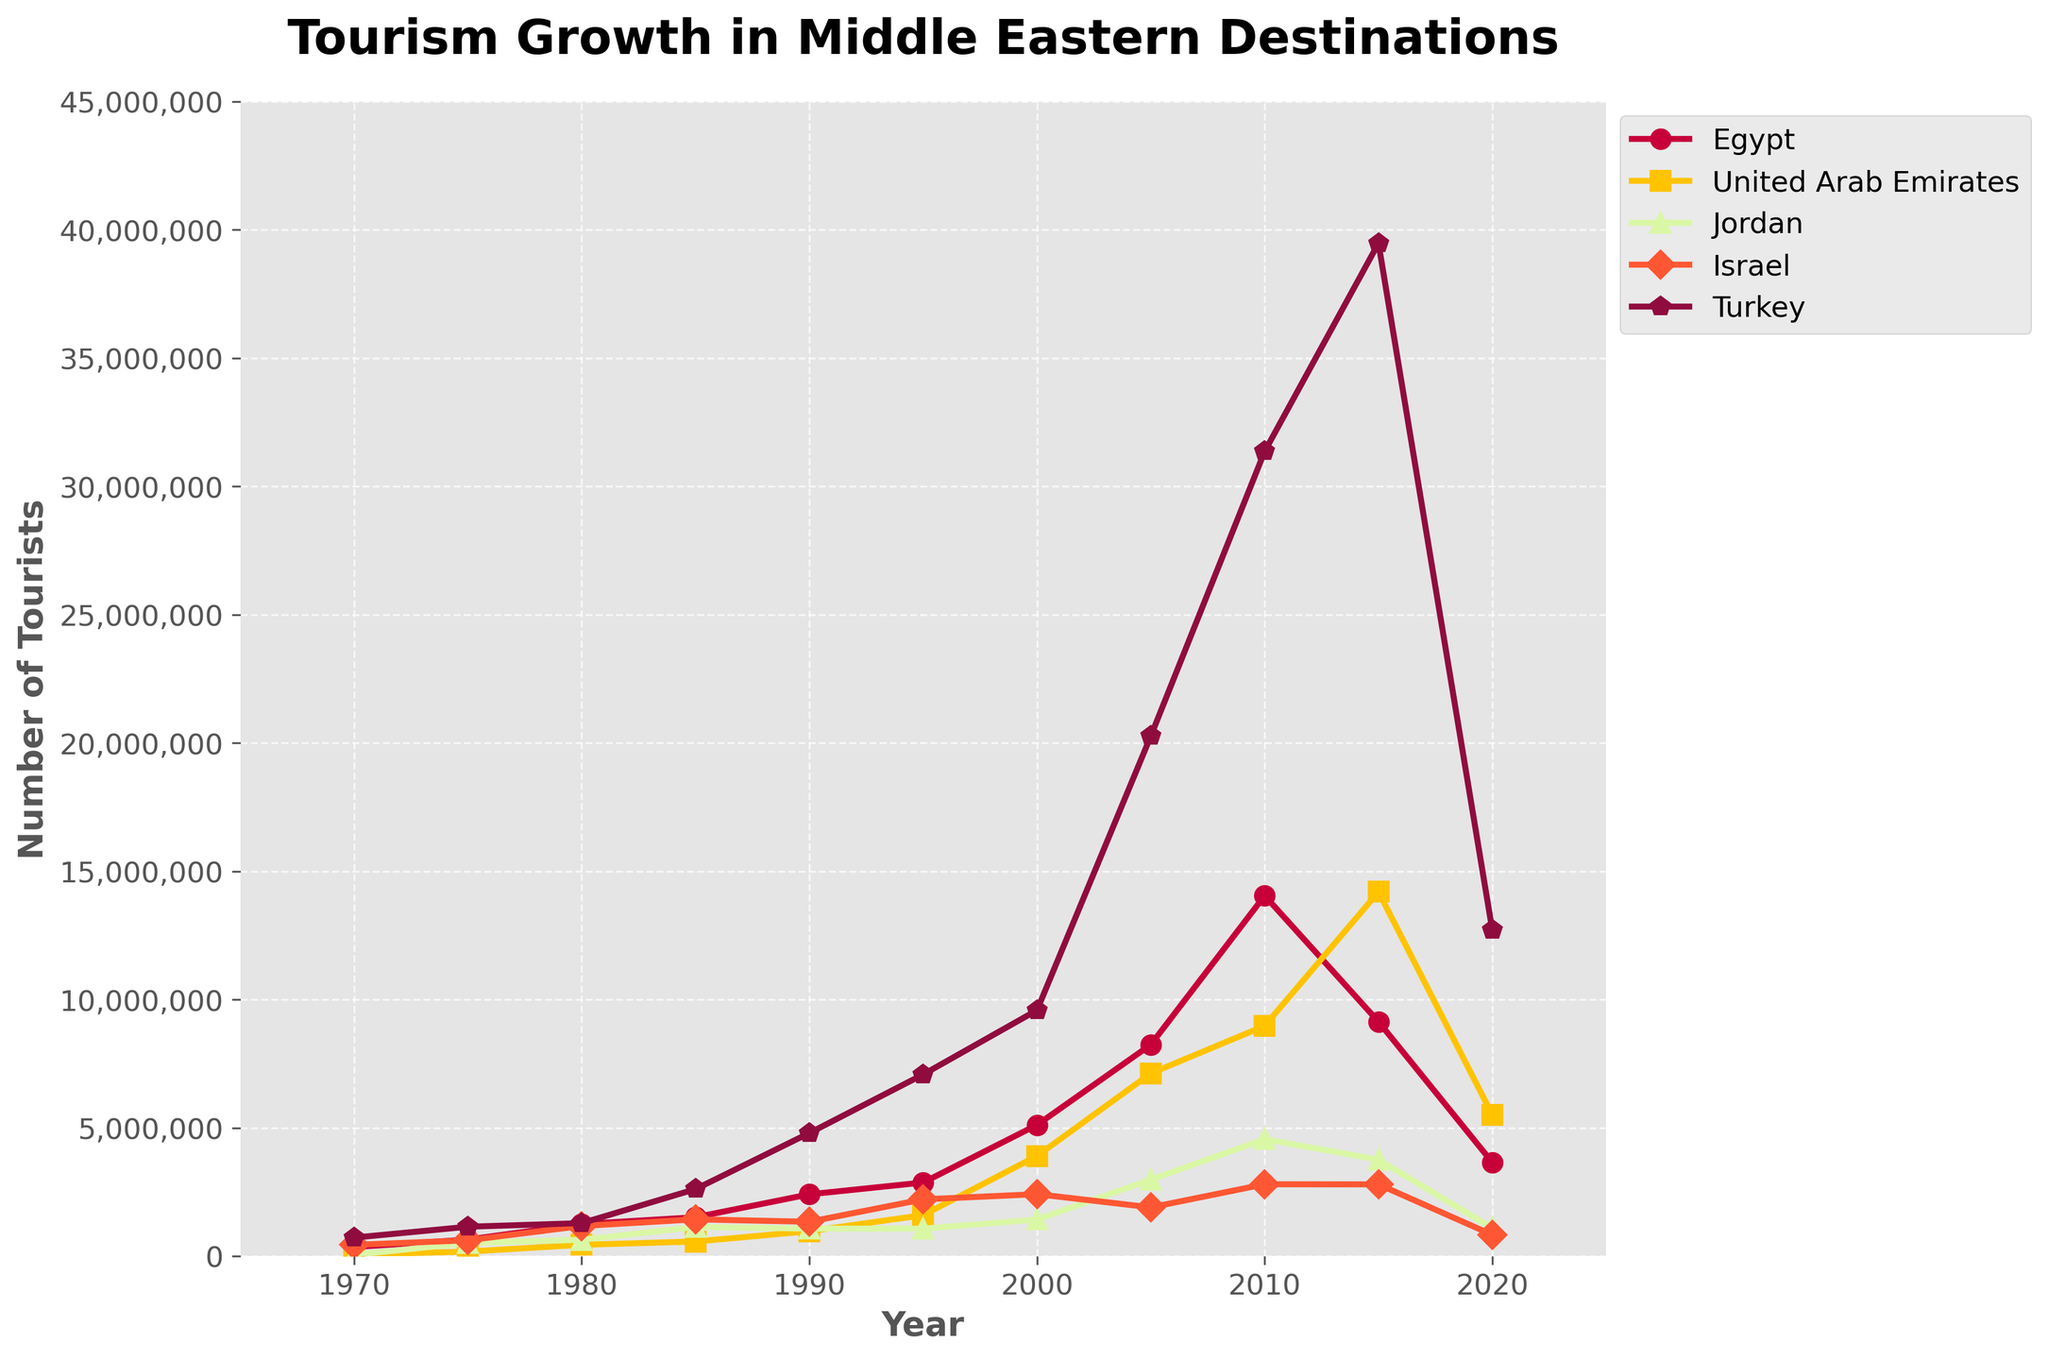Which country had the highest number of tourists in 2015? By looking at the year 2015 on the x-axis and identifying the tallest data point, Turkey had the highest number of tourists at nearly 39,478,000.
Answer: Turkey Which country experienced the most significant increase in tourism from 1970 to 2000? To determine the most significant increase, find the difference in the number of tourists for each country between 1970 and 2000. Turkey's increase from 724,000 to 9,586,000 is the most significant.
Answer: Turkey Among all countries, which had a similar number of tourists around the year 1990? By checking the y-axis values around the year 1990, Jordan and Israel had similar tourist numbers, around 1,075,000 and 1,342,000 respectively.
Answer: Jordan and Israel Which country saw a decline in tourist numbers between 2015 and 2020, and by how much? By comparing the data points between 2015 and 2020 for each country, UAE's tourist numbers declined significantly from 14,200,000 to 5,510,000. The decline is 14,200,000 - 5,510,000 = 8,690,000.
Answer: United Arab Emirates, 8,690,000 What year did Egypt surpass 10 million tourists? By tracing the graph, Egypt surpassed 10 million tourists in the year 2010.
Answer: 2010 What is the average number of tourists to Israel between 2000 and 2015? Calculate the average of the number of tourists to Israel from 2000 to 2015: (2,417,000 + 1,903,000 + 2,803,000 + 2,799,000)/4 = 2,480,500.
Answer: 2,480,500 In which decade did Turkey experience the sharpest increase in tourism? By examining the slope of Turkey's line graph, the sharpest increase occurred between 2005 and 2015.
Answer: 2005 to 2015 Which country had fewer tourists in 2020 than in 1985? Compare the data for 1985 and 2020 for each country. Jordan had fewer tourists in 2020 (1,090,000) than in 1985 (1,140,000).
Answer: Jordan In 2010, how did the number of tourists to the UAE compare to those to Egypt? Compare the data points for the UAE and Egypt in 2010. UAE had about 8,977,000 tourists, whereas Egypt had about 14,051,000. The UAE had fewer tourists.
Answer: UAE had fewer tourists than Egypt Which country showed consistent growth in tourism without any declines? Tracing each line from start to end, Turkey's number of tourists consistently grew over the decades without declines.
Answer: Turkey 